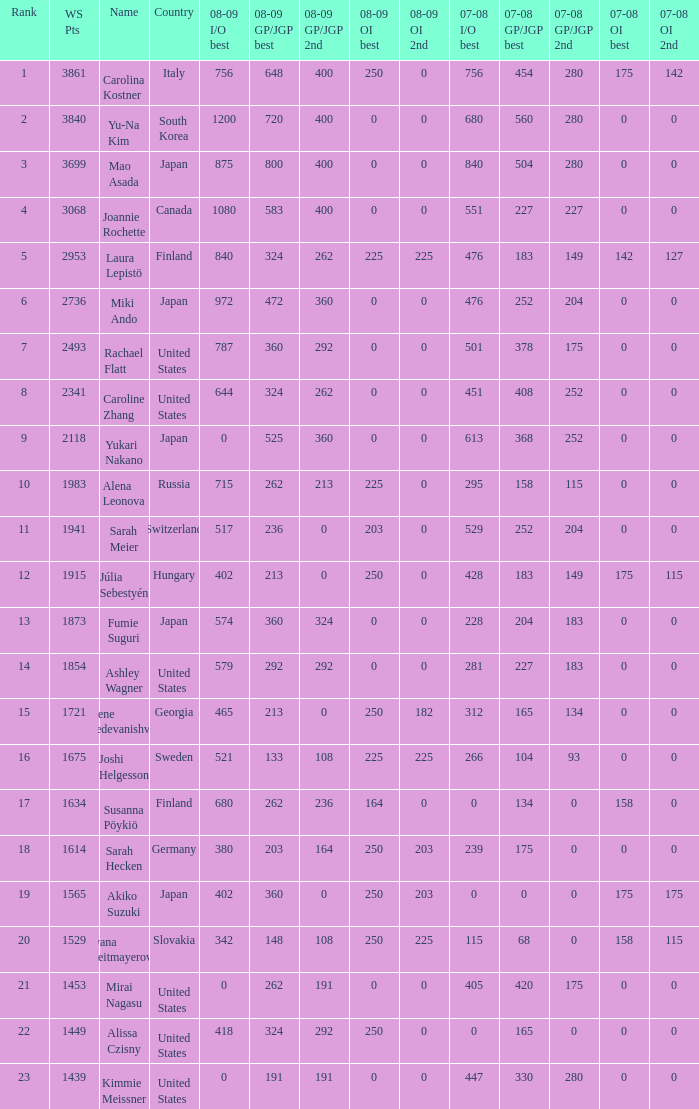What is the total 07-08 gp/jgp 2nd with the name mao asada 280.0. 